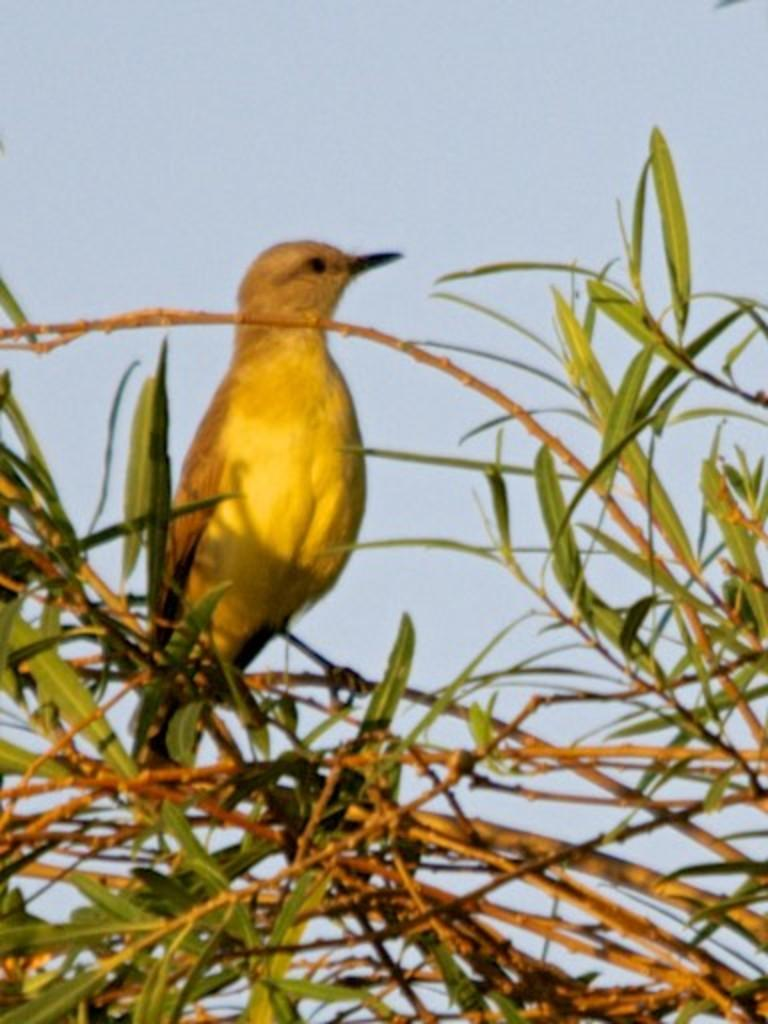What is the main object in the image? There is a tree in the image. How is the tree depicted? The tree is truncated towards the bottom. Are there any animals on the tree? Yes, there is a bird on the tree. What can be seen in the background of the image? The sky is visible in the background of the image. How is the sky depicted? The sky is truncated. What type of box is covering the bird on the tree? There is no box covering the bird on the tree in the image. Is the bird wearing a veil in the image? No, the bird is not wearing a veil in the image. 